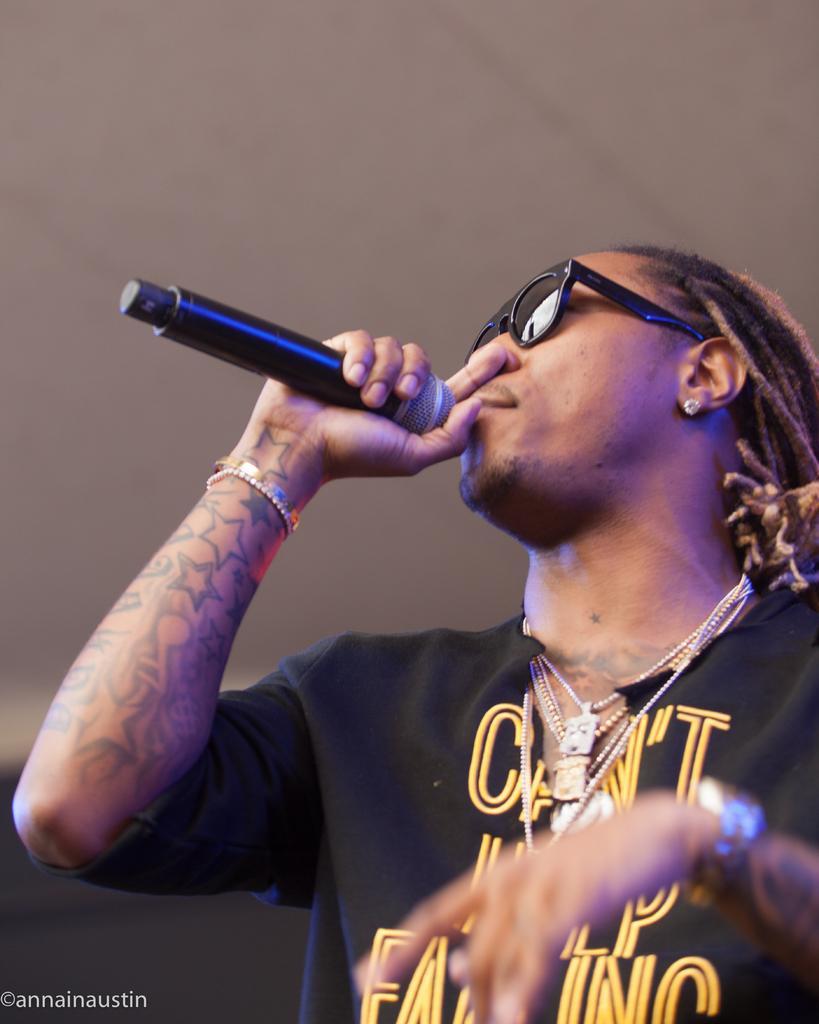Describe this image in one or two sentences. The man in black T-shirt who is wearing spectacles is holding a microphone in his hand. He is singing on the microphone. At the top of the picture, we see a wall which is white in color. 